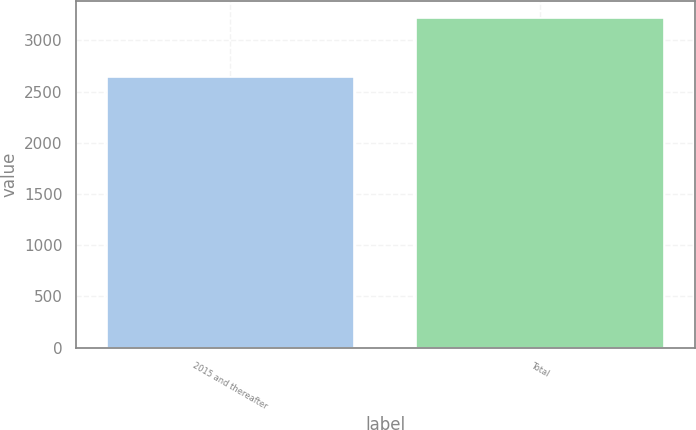Convert chart to OTSL. <chart><loc_0><loc_0><loc_500><loc_500><bar_chart><fcel>2015 and thereafter<fcel>Total<nl><fcel>2643<fcel>3222<nl></chart> 